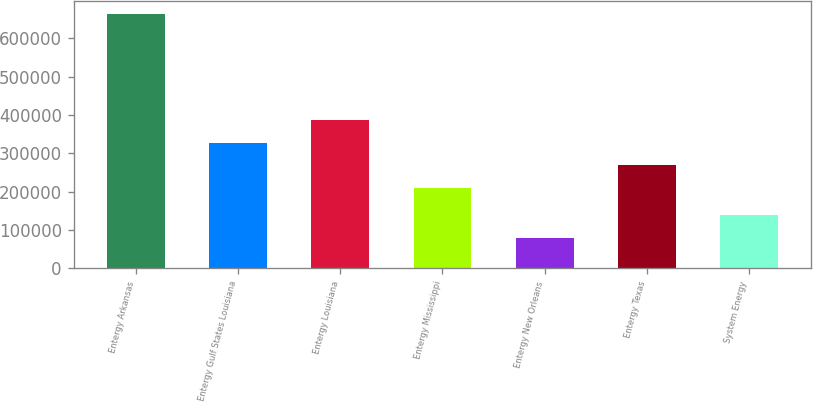<chart> <loc_0><loc_0><loc_500><loc_500><bar_chart><fcel>Entergy Arkansas<fcel>Entergy Gulf States Louisiana<fcel>Entergy Louisiana<fcel>Entergy Mississippi<fcel>Entergy New Orleans<fcel>Entergy Texas<fcel>System Energy<nl><fcel>664122<fcel>327184<fcel>387512<fcel>210314<fcel>79773<fcel>268749<fcel>138208<nl></chart> 